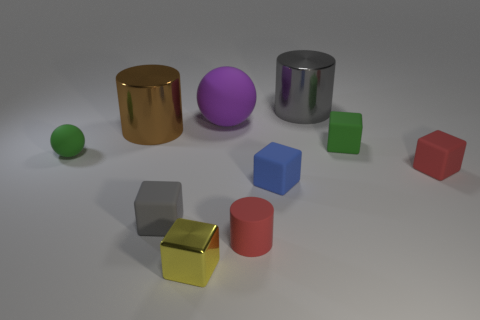Are there any tiny green things on the right side of the small green rubber sphere that is in front of the large cylinder that is to the right of the large brown cylinder?
Give a very brief answer. Yes. What size is the shiny thing that is both behind the tiny yellow cube and left of the gray metal thing?
Make the answer very short. Large. How many brown things are made of the same material as the small yellow block?
Provide a short and direct response. 1. What number of cylinders are gray matte things or green rubber objects?
Offer a terse response. 0. Is the number of green objects the same as the number of large purple objects?
Give a very brief answer. No. What size is the thing in front of the small red rubber object on the left side of the metal cylinder that is to the right of the small metallic thing?
Provide a succinct answer. Small. There is a cylinder that is both behind the red rubber cylinder and right of the purple object; what color is it?
Give a very brief answer. Gray. Does the gray rubber cube have the same size as the green matte thing to the left of the yellow block?
Offer a very short reply. Yes. Is there any other thing that is the same shape as the big gray metal object?
Ensure brevity in your answer.  Yes. The metallic thing that is the same shape as the gray rubber thing is what color?
Keep it short and to the point. Yellow. 